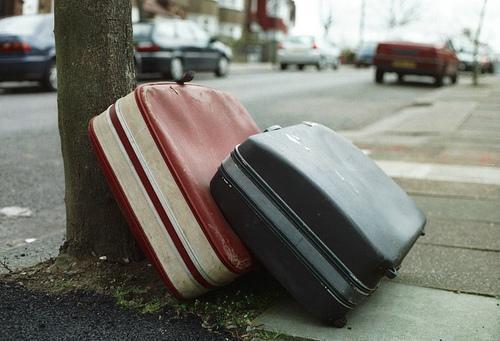How many suitcases are shown?
Give a very brief answer. 2. How many cars are in the photo?
Give a very brief answer. 3. How many people are wearing sunglasses in this photo?
Give a very brief answer. 0. 